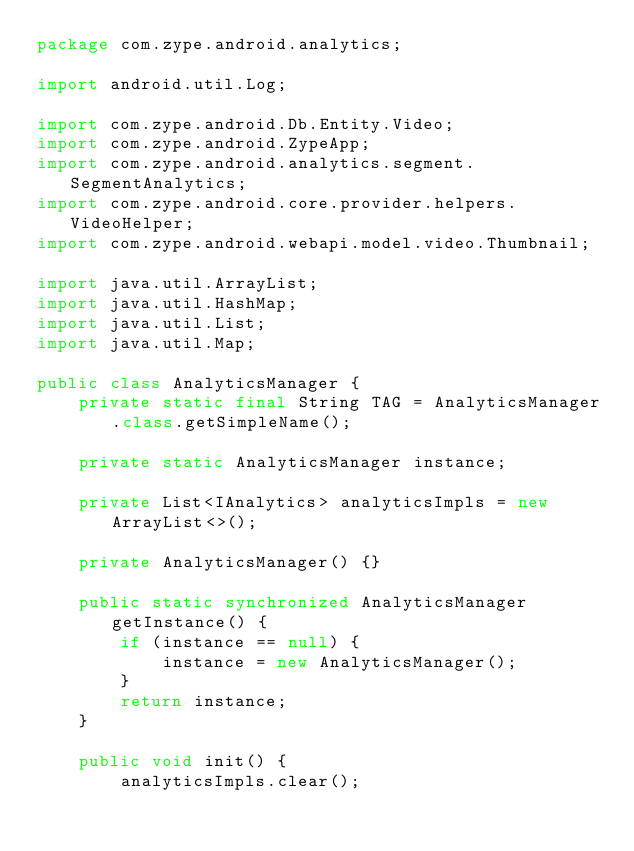Convert code to text. <code><loc_0><loc_0><loc_500><loc_500><_Java_>package com.zype.android.analytics;

import android.util.Log;

import com.zype.android.Db.Entity.Video;
import com.zype.android.ZypeApp;
import com.zype.android.analytics.segment.SegmentAnalytics;
import com.zype.android.core.provider.helpers.VideoHelper;
import com.zype.android.webapi.model.video.Thumbnail;

import java.util.ArrayList;
import java.util.HashMap;
import java.util.List;
import java.util.Map;

public class AnalyticsManager {
    private static final String TAG = AnalyticsManager.class.getSimpleName();

    private static AnalyticsManager instance;

    private List<IAnalytics> analyticsImpls = new ArrayList<>();

    private AnalyticsManager() {}

    public static synchronized AnalyticsManager getInstance() {
        if (instance == null) {
            instance = new AnalyticsManager();
        }
        return instance;
    }

    public void init() {
        analyticsImpls.clear();</code> 